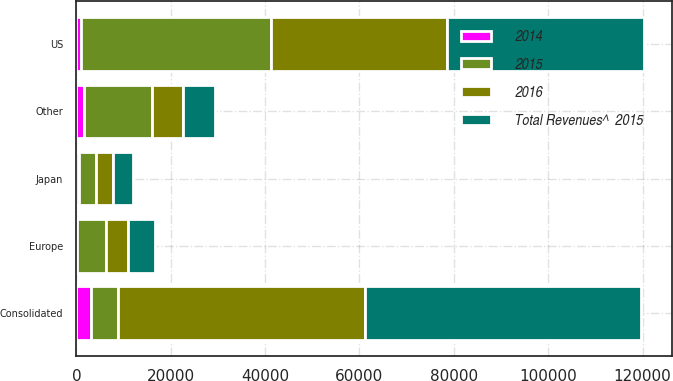Convert chart to OTSL. <chart><loc_0><loc_0><loc_500><loc_500><stacked_bar_chart><ecel><fcel>US<fcel>Europe<fcel>Japan<fcel>Other<fcel>Consolidated<nl><fcel>2016<fcel>37405<fcel>4613<fcel>3636<fcel>6713<fcel>52367<nl><fcel>Total Revenues^  2015<fcel>41623<fcel>5772<fcel>4293<fcel>6639<fcel>58327<nl><fcel>2015<fcel>40291<fcel>6140<fcel>3641<fcel>14334<fcel>5772<nl><fcel>2014<fcel>912<fcel>171<fcel>449<fcel>1603<fcel>3135<nl></chart> 